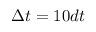Convert formula to latex. <formula><loc_0><loc_0><loc_500><loc_500>\Delta t = 1 0 d t</formula> 